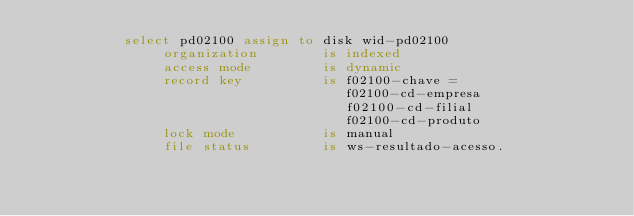Convert code to text. <code><loc_0><loc_0><loc_500><loc_500><_COBOL_>           select pd02100 assign to disk wid-pd02100
                organization        is indexed
                access mode         is dynamic
                record key          is f02100-chave = 
                                       f02100-cd-empresa
                                       f02100-cd-filial
                                       f02100-cd-produto                                      
                lock mode           is manual
                file status         is ws-resultado-acesso.

      


</code> 